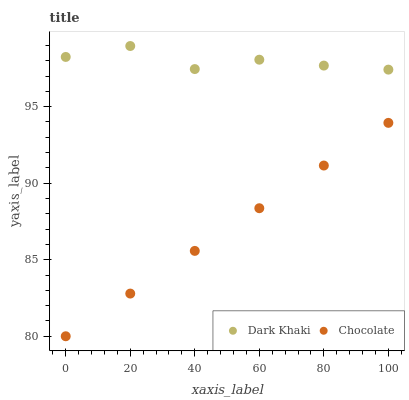Does Chocolate have the minimum area under the curve?
Answer yes or no. Yes. Does Dark Khaki have the maximum area under the curve?
Answer yes or no. Yes. Does Chocolate have the maximum area under the curve?
Answer yes or no. No. Is Chocolate the smoothest?
Answer yes or no. Yes. Is Dark Khaki the roughest?
Answer yes or no. Yes. Is Chocolate the roughest?
Answer yes or no. No. Does Chocolate have the lowest value?
Answer yes or no. Yes. Does Dark Khaki have the highest value?
Answer yes or no. Yes. Does Chocolate have the highest value?
Answer yes or no. No. Is Chocolate less than Dark Khaki?
Answer yes or no. Yes. Is Dark Khaki greater than Chocolate?
Answer yes or no. Yes. Does Chocolate intersect Dark Khaki?
Answer yes or no. No. 